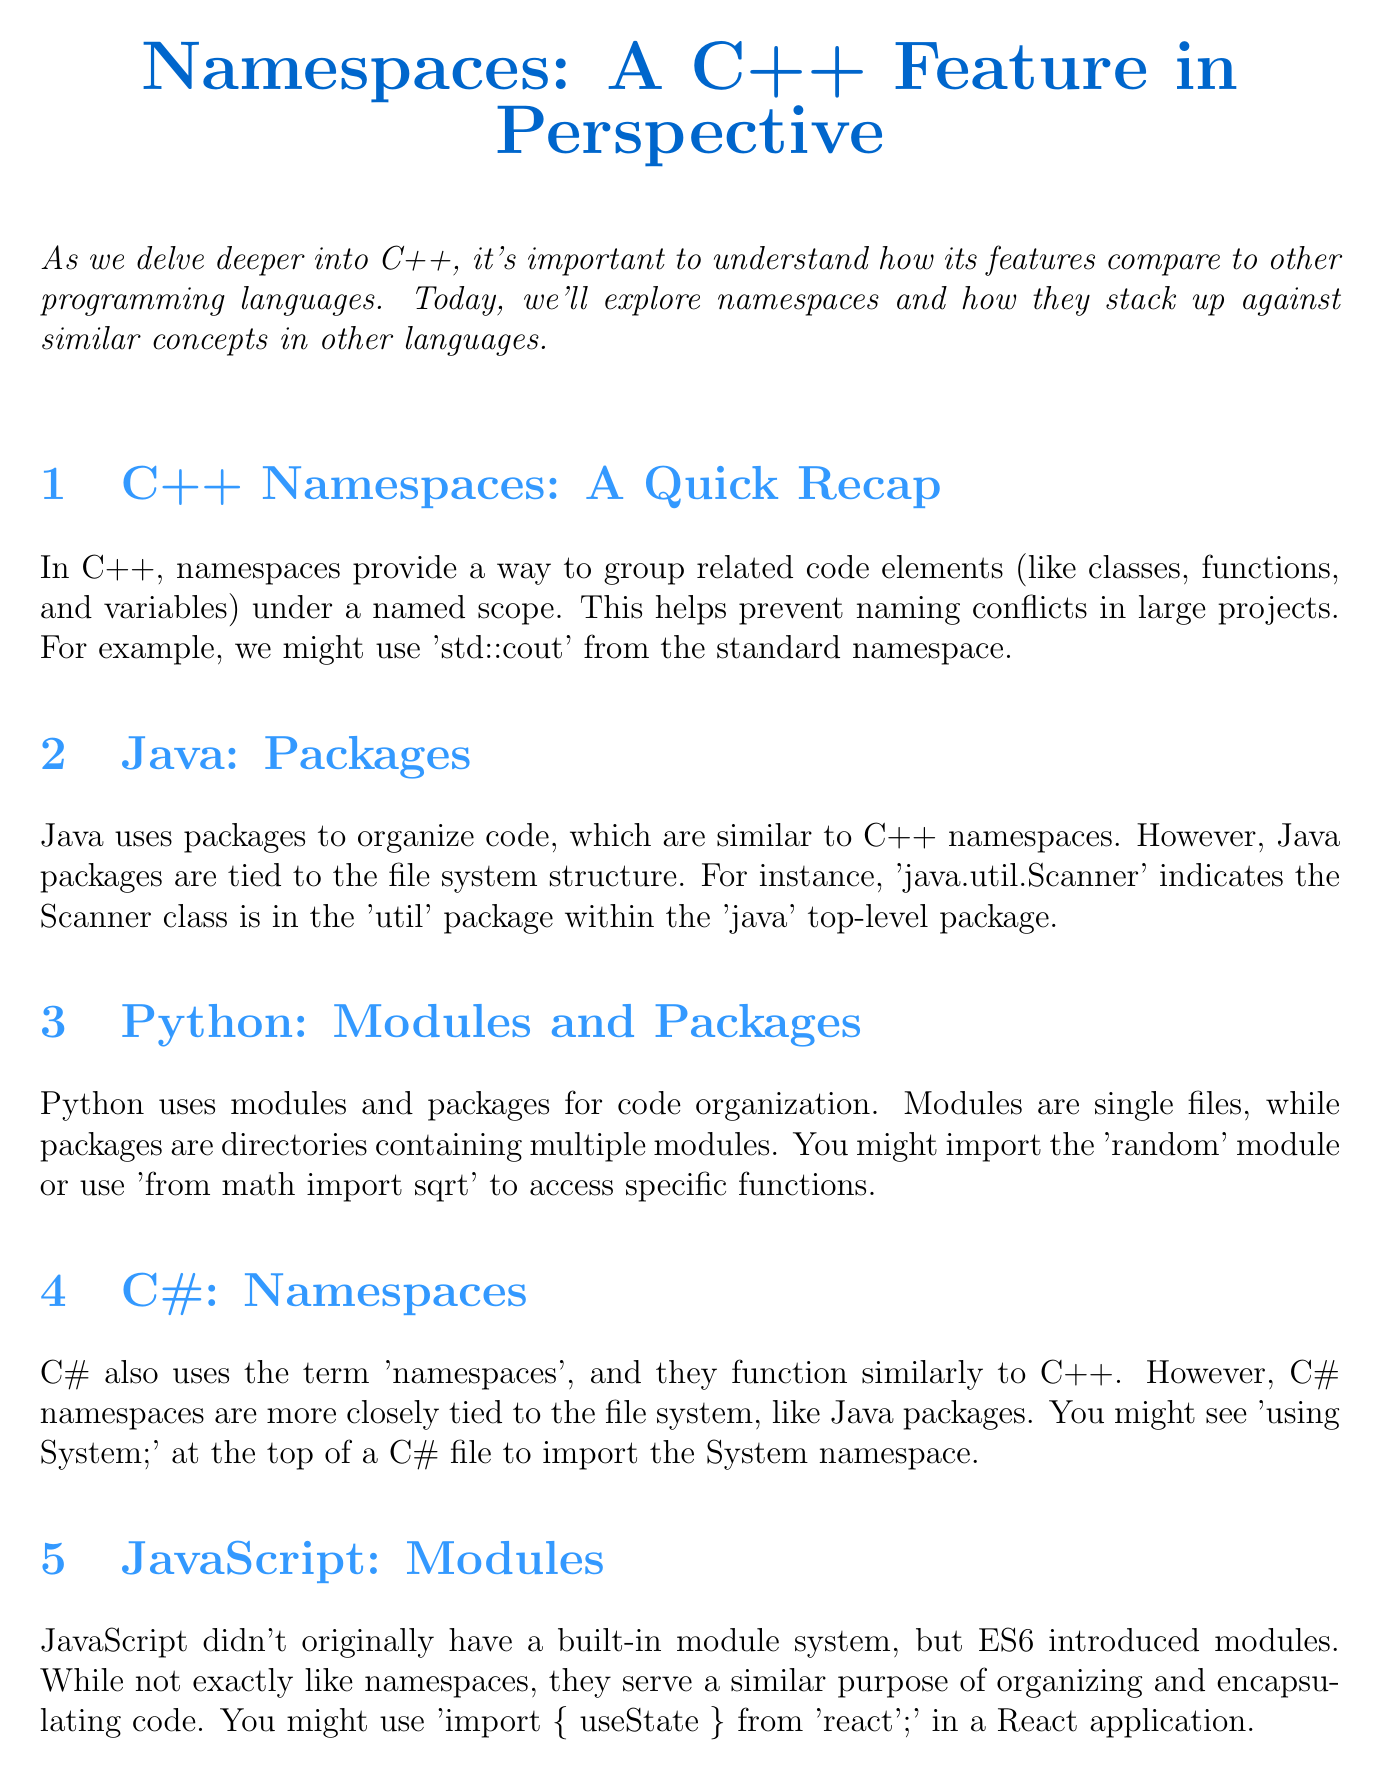What is the title of the newsletter? The title of the newsletter is presented at the top of the document.
Answer: Namespaces: A C++ Feature in Perspective What does C++ use namespaces for? The document specifies that namespaces group related code elements to prevent naming conflicts.
Answer: Group related code elements What are Java's organizational structures compared to C++ namespaces? The document states that Java uses packages to organize code, which are similar to C++ namespaces.
Answer: Packages In Python, what is a single file used for code organization called? The document explains that a single file in Python is referred to as a module.
Answer: Module What is the objective of the classroom activity described? The objective of the classroom activity is provided in a specific section of the document.
Answer: Help students understand Which programming language's namespaces are closely tied to the file system like Java? The document mentions that C# namespaces are more closely tied to the file system.
Answer: C# What does the document suggest about JavaScript's modules? The document indicates that JavaScript modules serve a similar purpose of organizing and encapsulating code.
Answer: Organizing and encapsulating code What does the conclusion emphasize about understanding C++ namespaces? The conclusion highlights the importance of understanding C++ namespaces in relation to other programming languages.
Answer: Broader context of namespaces What should groups focus on during the classroom activity? The description of the activity mentions that groups should focus on syntax and use cases.
Answer: Syntax and use cases 